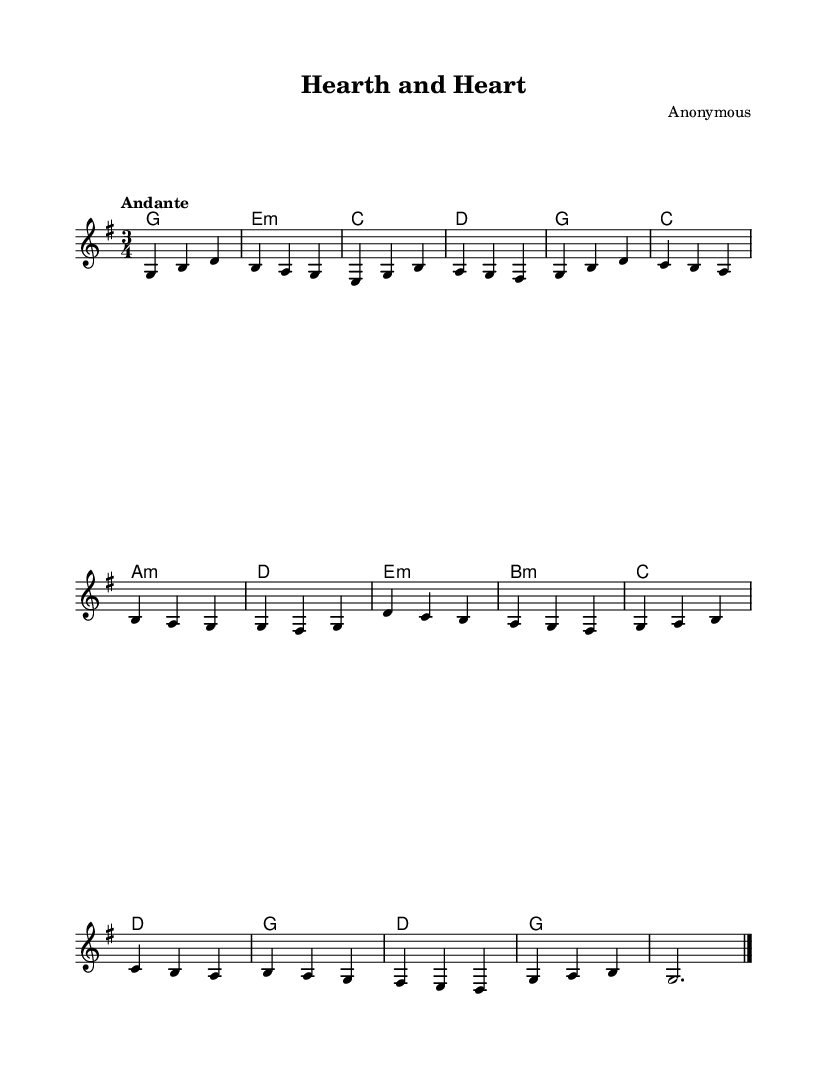What is the key signature of this music? The key signature is G major, which has one sharp (F#). This can be determined by looking at the key signature indicated at the beginning of the piece.
Answer: G major What is the time signature of this piece? The time signature is 3/4, which is indicated at the beginning of the sheet music and suggests three beats per measure with a quarter note receiving one beat.
Answer: 3/4 What is the tempo marking for this piece? The tempo marking is "Andante," which denotes a moderately slow tempo. This is found above the staff at the beginning of the score.
Answer: Andante How many measures are in the melody? The melody consists of 16 measures, which can be counted by counting the number of bar lines in the melody section of the sheet music.
Answer: 16 Which chord comes after the G major chord? The chord that comes after the G major chord is E minor. This can be identified by looking at the chord symbols written above the staff in the harmonies section, where the sequence of chords is indicated.
Answer: E minor What is the last note in the melody? The last note in the melody is G. This can be determined by looking closely at the final measure of the melody, where the last note is clearly indicated.
Answer: G What is the relationship between the melody and harmonies? The melody is primarily harmonized using chords that complement its structure, displaying typical characteristics of Romantic music with a flowing and emotional context. This conclusion can be reached by analyzing how the melody notes correspond with the chords indicated above throughout the piece.
Answer: Complementary harmonization 